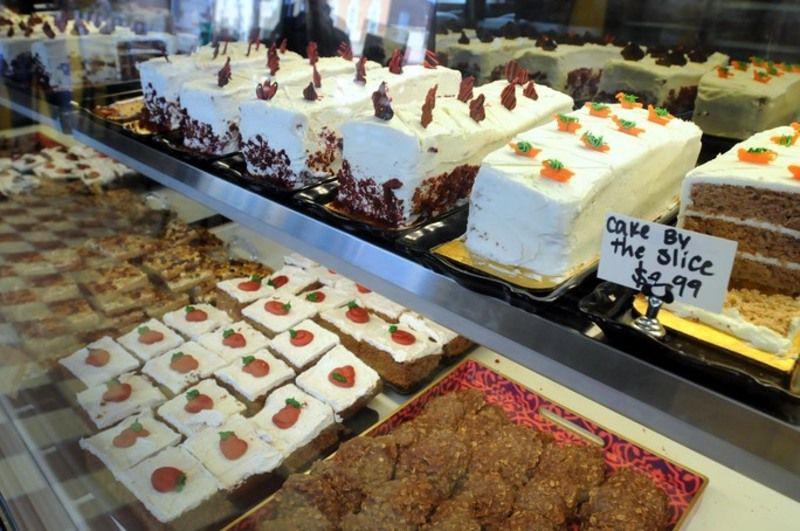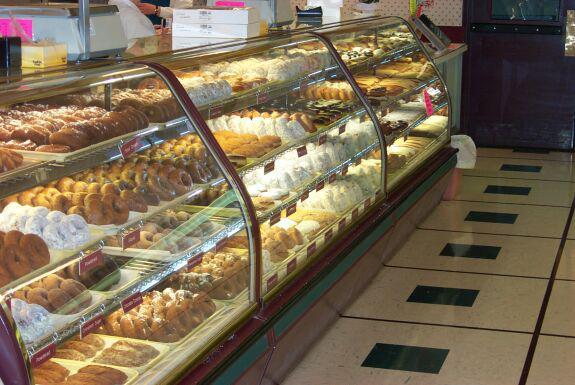The first image is the image on the left, the second image is the image on the right. For the images shown, is this caption "The display case on the right contains mostly round cake-like desserts that aren't covered in sliced fruits." true? Answer yes or no. No. 